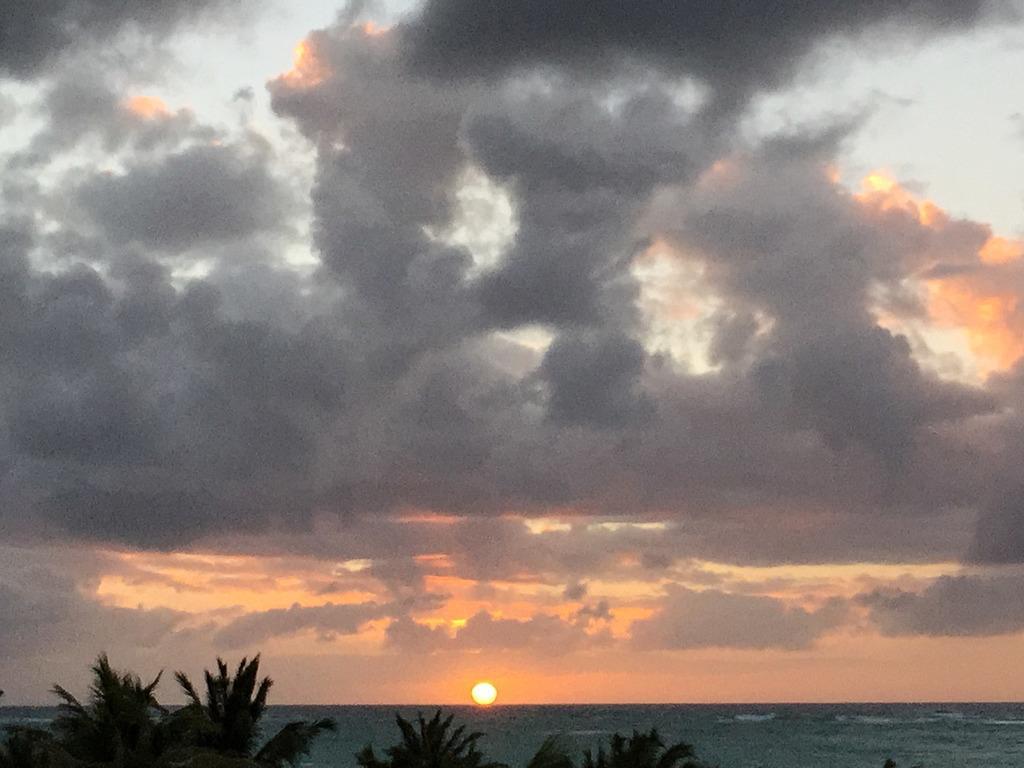How would you summarize this image in a sentence or two? As we can see in the image there are trees, water and sun. On the top there is sky and clouds. 